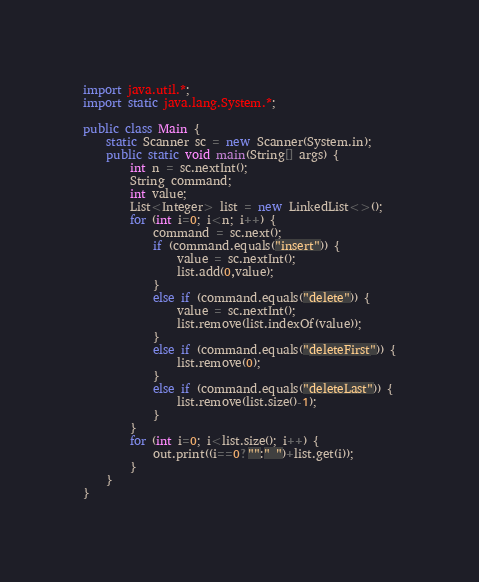Convert code to text. <code><loc_0><loc_0><loc_500><loc_500><_Java_>import java.util.*;
import static java.lang.System.*;

public class Main {
	static Scanner sc = new Scanner(System.in);
	public static void main(String[] args) {
		int n = sc.nextInt();
		String command;
		int value;
		List<Integer> list = new LinkedList<>();
		for (int i=0; i<n; i++) {
			command = sc.next();
			if (command.equals("insert")) {
				value = sc.nextInt();
				list.add(0,value);
			}
			else if (command.equals("delete")) {
				value = sc.nextInt();
				list.remove(list.indexOf(value));
			}
			else if (command.equals("deleteFirst")) {
				list.remove(0);
			}
			else if (command.equals("deleteLast")) {
				list.remove(list.size()-1);
			}
		}
		for (int i=0; i<list.size(); i++) {
			out.print((i==0?"":" ")+list.get(i));
		}
	}
}
</code> 